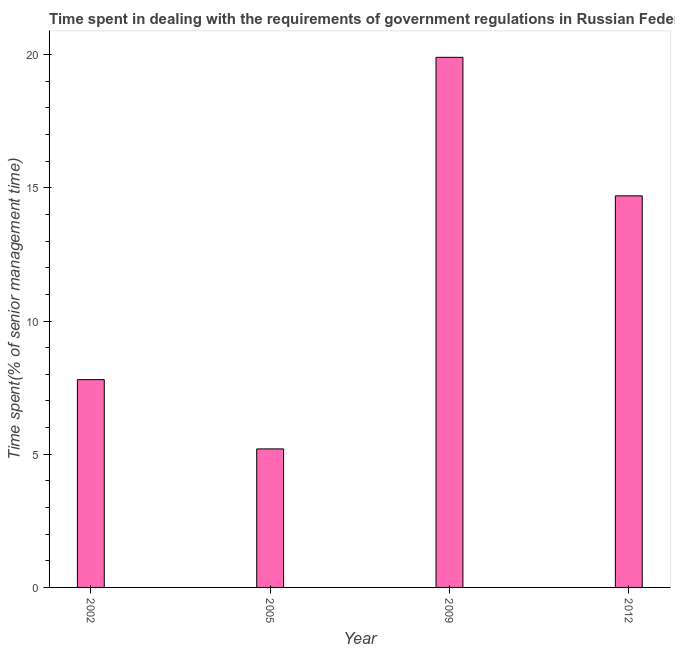What is the title of the graph?
Provide a short and direct response. Time spent in dealing with the requirements of government regulations in Russian Federation. What is the label or title of the Y-axis?
Ensure brevity in your answer.  Time spent(% of senior management time). What is the time spent in dealing with government regulations in 2002?
Give a very brief answer. 7.8. Across all years, what is the maximum time spent in dealing with government regulations?
Ensure brevity in your answer.  19.9. Across all years, what is the minimum time spent in dealing with government regulations?
Provide a succinct answer. 5.2. What is the sum of the time spent in dealing with government regulations?
Provide a short and direct response. 47.6. What is the difference between the time spent in dealing with government regulations in 2002 and 2005?
Offer a very short reply. 2.6. What is the average time spent in dealing with government regulations per year?
Offer a terse response. 11.9. What is the median time spent in dealing with government regulations?
Your response must be concise. 11.25. In how many years, is the time spent in dealing with government regulations greater than 15 %?
Ensure brevity in your answer.  1. What is the ratio of the time spent in dealing with government regulations in 2005 to that in 2012?
Ensure brevity in your answer.  0.35. What is the difference between the highest and the lowest time spent in dealing with government regulations?
Offer a very short reply. 14.7. How many bars are there?
Give a very brief answer. 4. Are all the bars in the graph horizontal?
Provide a succinct answer. No. What is the Time spent(% of senior management time) of 2005?
Provide a succinct answer. 5.2. What is the Time spent(% of senior management time) of 2012?
Your response must be concise. 14.7. What is the difference between the Time spent(% of senior management time) in 2002 and 2009?
Provide a short and direct response. -12.1. What is the difference between the Time spent(% of senior management time) in 2002 and 2012?
Ensure brevity in your answer.  -6.9. What is the difference between the Time spent(% of senior management time) in 2005 and 2009?
Make the answer very short. -14.7. What is the ratio of the Time spent(% of senior management time) in 2002 to that in 2005?
Your answer should be compact. 1.5. What is the ratio of the Time spent(% of senior management time) in 2002 to that in 2009?
Your answer should be very brief. 0.39. What is the ratio of the Time spent(% of senior management time) in 2002 to that in 2012?
Provide a succinct answer. 0.53. What is the ratio of the Time spent(% of senior management time) in 2005 to that in 2009?
Your answer should be compact. 0.26. What is the ratio of the Time spent(% of senior management time) in 2005 to that in 2012?
Your answer should be compact. 0.35. What is the ratio of the Time spent(% of senior management time) in 2009 to that in 2012?
Provide a succinct answer. 1.35. 